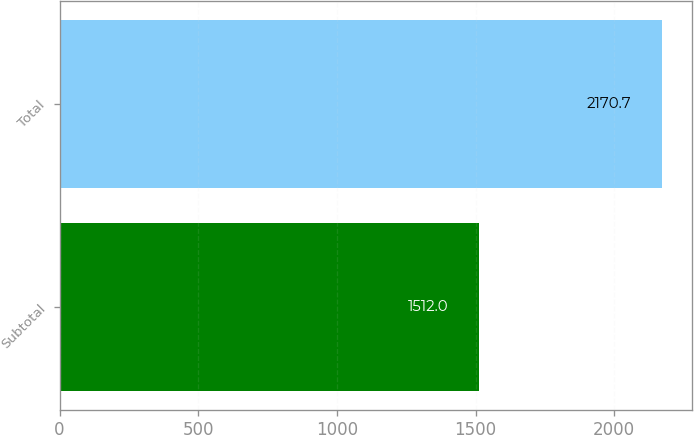Convert chart to OTSL. <chart><loc_0><loc_0><loc_500><loc_500><bar_chart><fcel>Subtotal<fcel>Total<nl><fcel>1512<fcel>2170.7<nl></chart> 